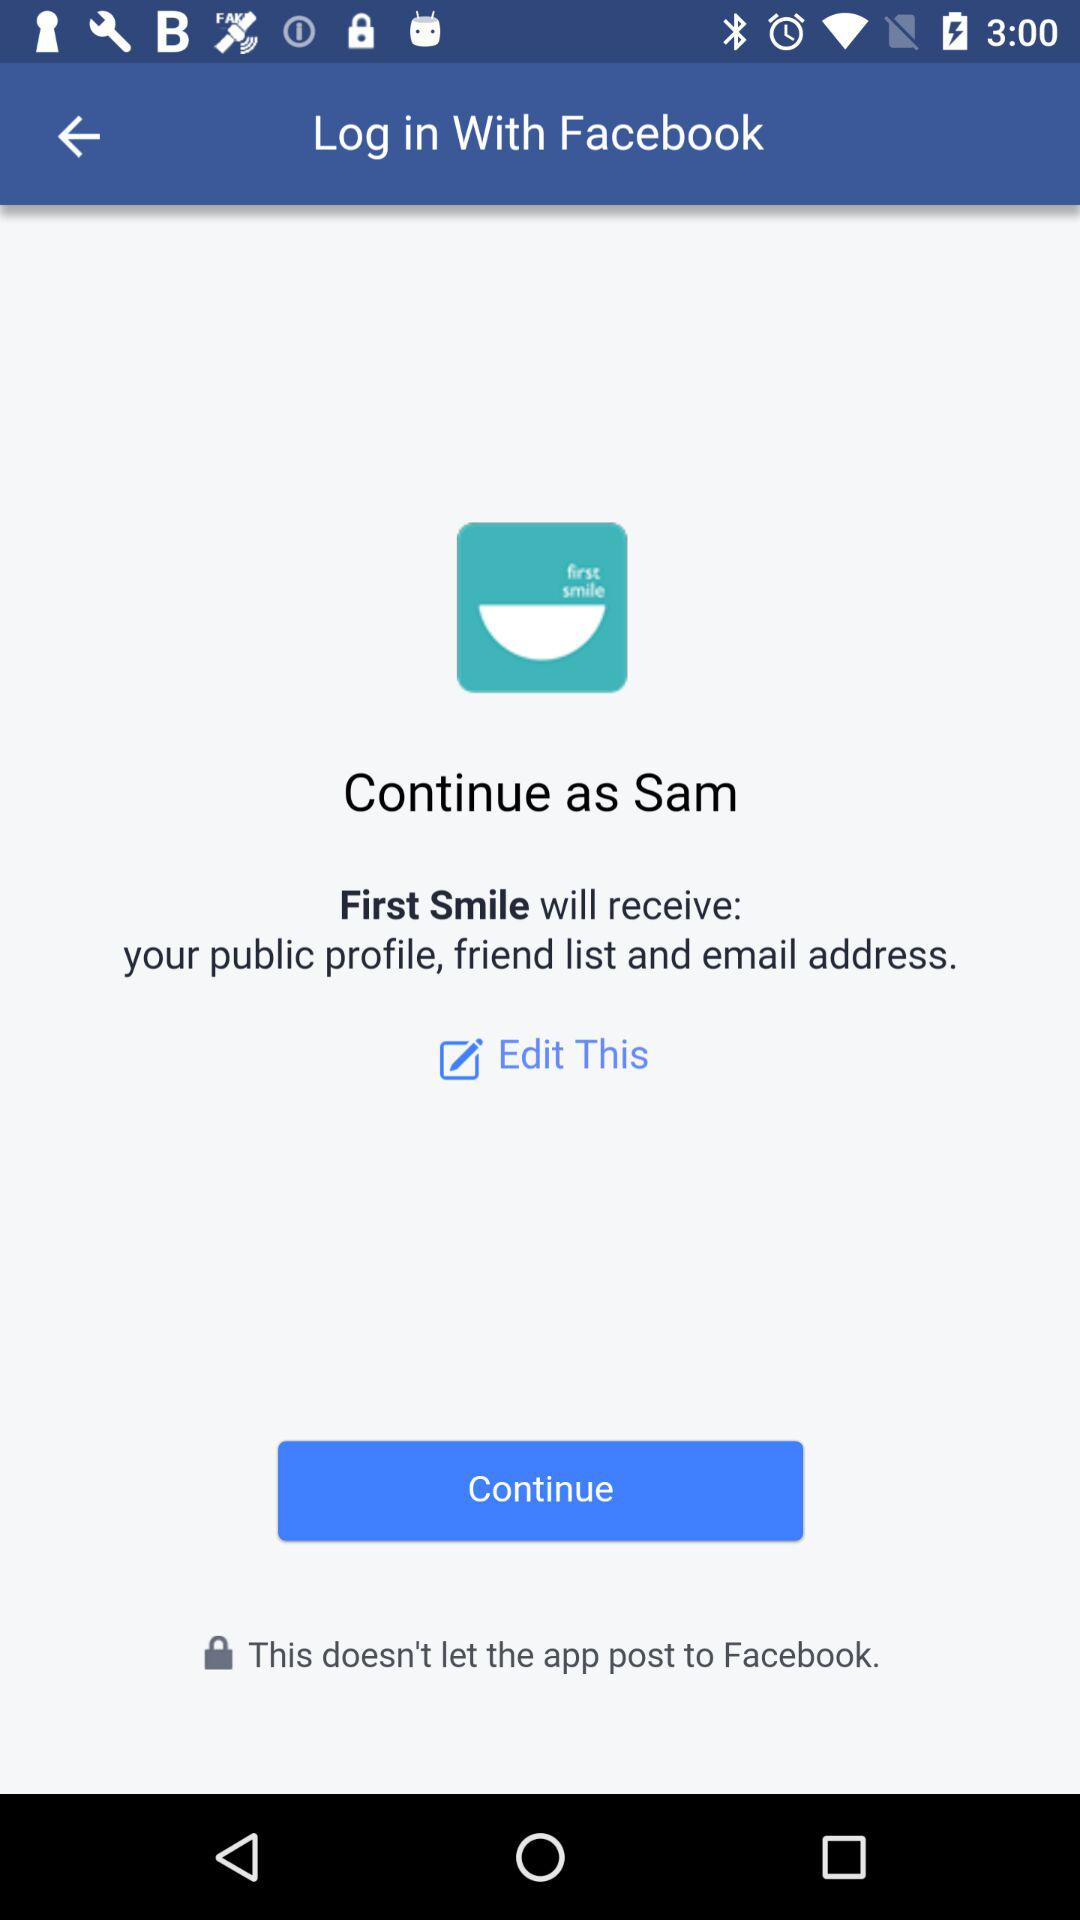What is the name of the user? The name of the user is Sam. 